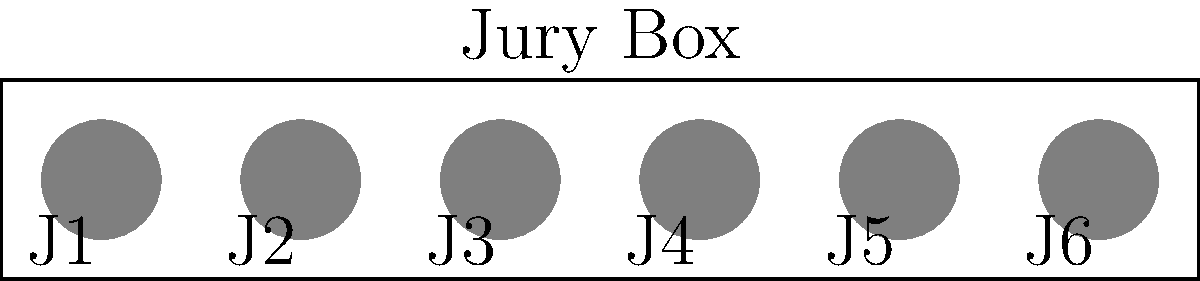In a high-profile case you're working on with Sandy Dawson, the judge decides to rearrange the jury seating to ensure impartiality. If there are 6 jurors as shown in the diagram, how many unique permutations of seating arrangements are possible? Let's approach this step-by-step:

1) We have 6 jurors, each of whom can be seated in any of the 6 positions.

2) This is a classic permutation problem. We're arranging 6 distinct objects (jurors) in 6 distinct positions.

3) For the first seat, we have 6 choices of jurors.

4) For the second seat, we have 5 remaining choices.

5) For the third seat, we have 4 choices, and so on.

6) This pattern continues until we place the last juror in the only remaining seat.

7) Mathematically, this is represented as:

   $$ 6 \times 5 \times 4 \times 3 \times 2 \times 1 $$

8) This is also known as 6 factorial, written as 6!

9) Calculating this:
   $$ 6! = 6 \times 5 \times 4 \times 3 \times 2 \times 1 = 720 $$

Therefore, there are 720 unique permutations of seating arrangements possible for the 6 jurors.
Answer: 720 